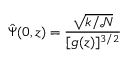Convert formula to latex. <formula><loc_0><loc_0><loc_500><loc_500>\hat { \Psi } ( 0 , z ) = \frac { \sqrt { k / { \mathcal { N } } } } { [ g ( z ) ] ^ { 3 / 2 } }</formula> 